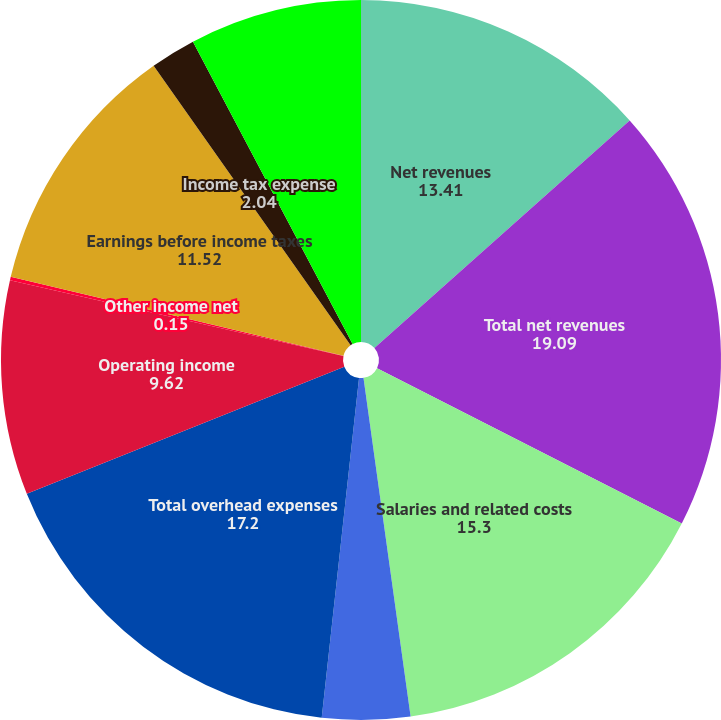<chart> <loc_0><loc_0><loc_500><loc_500><pie_chart><fcel>Net revenues<fcel>Total net revenues<fcel>Salaries and related costs<fcel>Other<fcel>Total overhead expenses<fcel>Operating income<fcel>Other income net<fcel>Earnings before income taxes<fcel>Income tax expense<fcel>Net earnings<nl><fcel>13.41%<fcel>19.09%<fcel>15.3%<fcel>3.94%<fcel>17.2%<fcel>9.62%<fcel>0.15%<fcel>11.52%<fcel>2.04%<fcel>7.73%<nl></chart> 